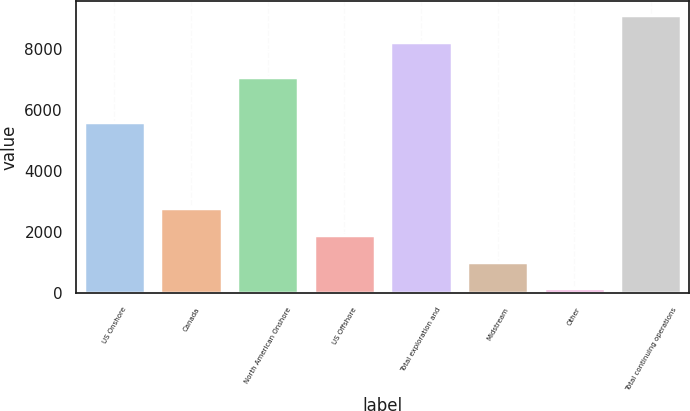Convert chart. <chart><loc_0><loc_0><loc_500><loc_500><bar_chart><fcel>US Onshore<fcel>Canada<fcel>North American Onshore<fcel>US Offshore<fcel>Total exploration and<fcel>Midstream<fcel>Other<fcel>Total continuing operations<nl><fcel>5606<fcel>2771.9<fcel>7065<fcel>1904.6<fcel>8222<fcel>1037.3<fcel>170<fcel>9089.3<nl></chart> 